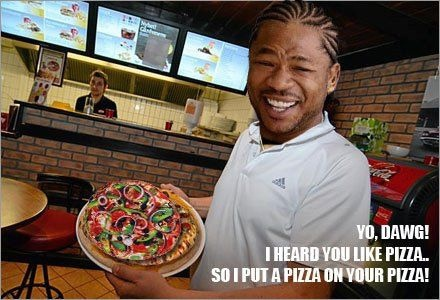Describe the objects in this image and their specific colors. I can see people in darkgray, lightgray, maroon, and gray tones, pizza in darkgray, maroon, brown, and olive tones, chair in darkgray, black, maroon, and brown tones, dining table in darkgray, olive, tan, and black tones, and people in darkgray, black, maroon, and gray tones in this image. 